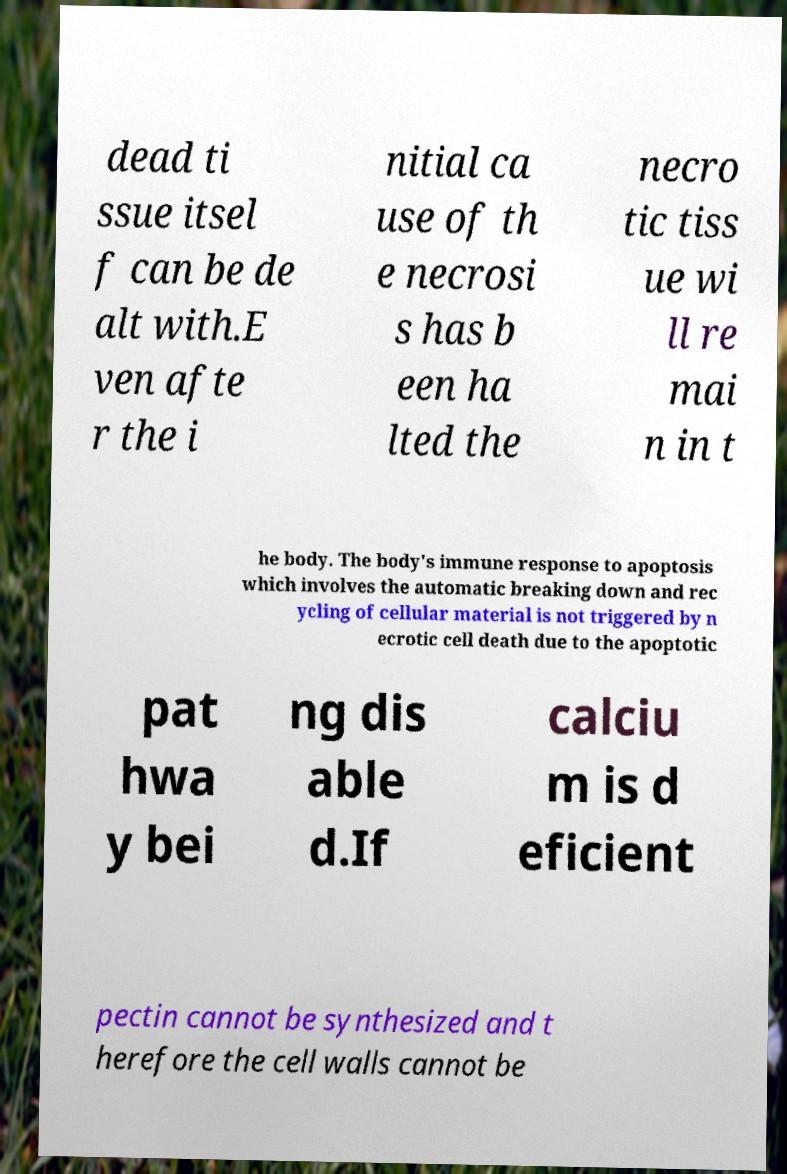For documentation purposes, I need the text within this image transcribed. Could you provide that? dead ti ssue itsel f can be de alt with.E ven afte r the i nitial ca use of th e necrosi s has b een ha lted the necro tic tiss ue wi ll re mai n in t he body. The body's immune response to apoptosis which involves the automatic breaking down and rec ycling of cellular material is not triggered by n ecrotic cell death due to the apoptotic pat hwa y bei ng dis able d.If calciu m is d eficient pectin cannot be synthesized and t herefore the cell walls cannot be 